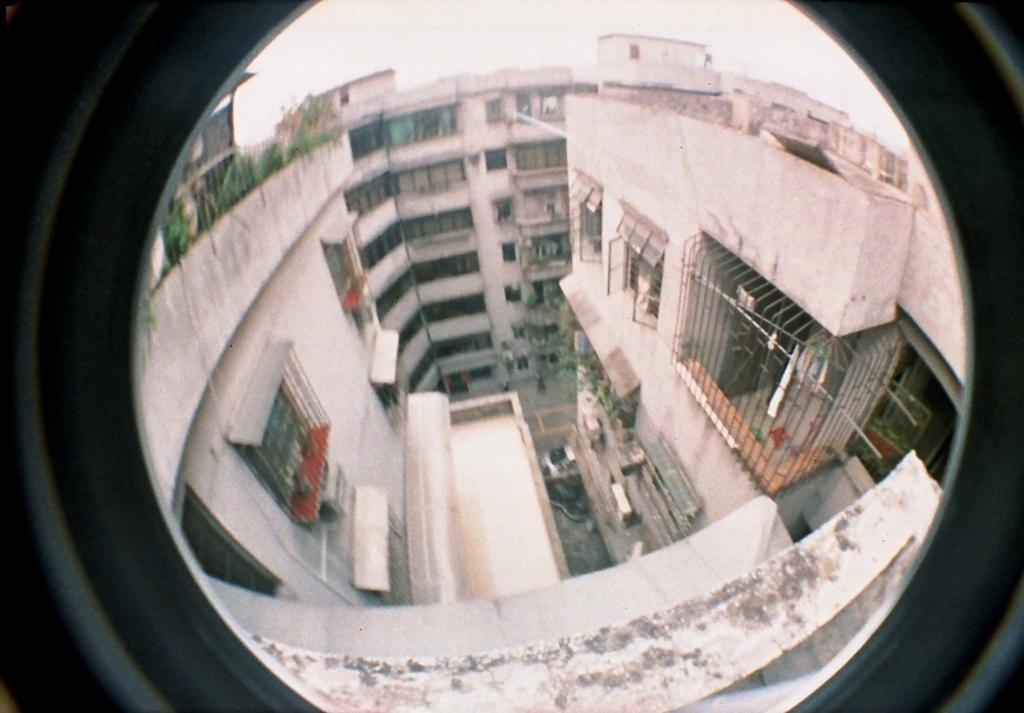What type of structures can be seen in the image? There are buildings in the image. What objects are used for cooking in the image? There are grills in the image. What type of vegetation is present in the image? There are plants in the image. What is being dried in the image? Clothes are hanged on ropes in the image. How was the image captured? The image was captured through a camera lens. What type of store can be seen in the image? There is no store present in the image. What type of thunder can be heard in the image? There is no sound, including thunder, present in the image, as it is a still photograph. 